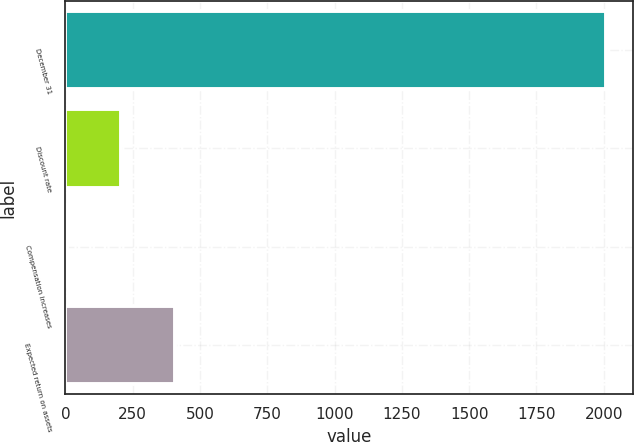Convert chart to OTSL. <chart><loc_0><loc_0><loc_500><loc_500><bar_chart><fcel>December 31<fcel>Discount rate<fcel>Compensation increases<fcel>Expected return on assets<nl><fcel>2009<fcel>204.68<fcel>4.2<fcel>405.16<nl></chart> 